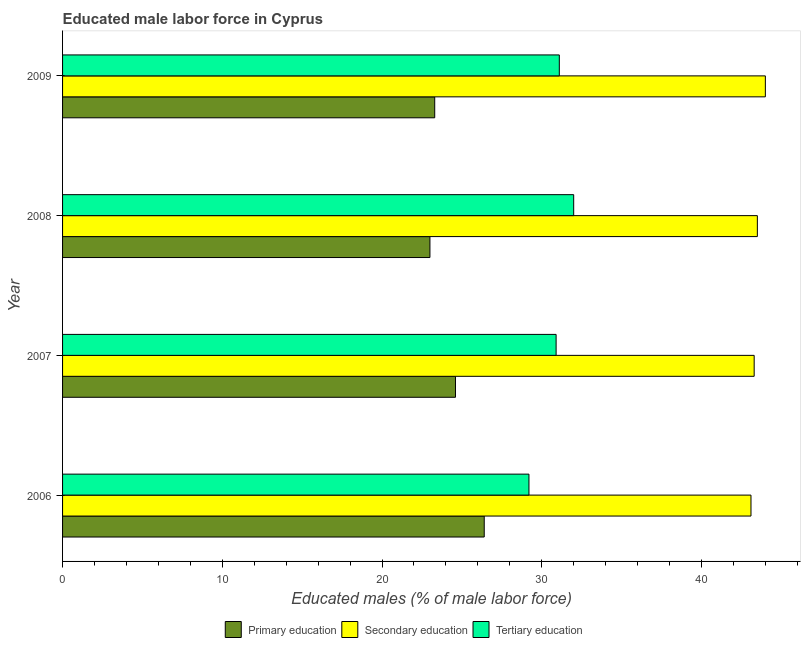How many different coloured bars are there?
Your answer should be compact. 3. How many groups of bars are there?
Your answer should be very brief. 4. Are the number of bars on each tick of the Y-axis equal?
Provide a succinct answer. Yes. What is the label of the 1st group of bars from the top?
Make the answer very short. 2009. In how many cases, is the number of bars for a given year not equal to the number of legend labels?
Provide a succinct answer. 0. What is the percentage of male labor force who received secondary education in 2007?
Provide a short and direct response. 43.3. In which year was the percentage of male labor force who received primary education maximum?
Make the answer very short. 2006. What is the total percentage of male labor force who received primary education in the graph?
Provide a short and direct response. 97.3. What is the difference between the percentage of male labor force who received tertiary education in 2006 and the percentage of male labor force who received primary education in 2009?
Make the answer very short. 5.9. What is the average percentage of male labor force who received secondary education per year?
Your answer should be compact. 43.48. In the year 2006, what is the difference between the percentage of male labor force who received primary education and percentage of male labor force who received secondary education?
Provide a succinct answer. -16.7. What is the ratio of the percentage of male labor force who received tertiary education in 2006 to that in 2007?
Your answer should be very brief. 0.94. Is the difference between the percentage of male labor force who received tertiary education in 2006 and 2009 greater than the difference between the percentage of male labor force who received primary education in 2006 and 2009?
Your answer should be very brief. No. In how many years, is the percentage of male labor force who received tertiary education greater than the average percentage of male labor force who received tertiary education taken over all years?
Give a very brief answer. 3. What does the 2nd bar from the top in 2006 represents?
Offer a terse response. Secondary education. What does the 1st bar from the bottom in 2007 represents?
Your answer should be compact. Primary education. Is it the case that in every year, the sum of the percentage of male labor force who received primary education and percentage of male labor force who received secondary education is greater than the percentage of male labor force who received tertiary education?
Ensure brevity in your answer.  Yes. Are all the bars in the graph horizontal?
Provide a succinct answer. Yes. How many years are there in the graph?
Offer a terse response. 4. What is the difference between two consecutive major ticks on the X-axis?
Keep it short and to the point. 10. Where does the legend appear in the graph?
Your answer should be very brief. Bottom center. What is the title of the graph?
Ensure brevity in your answer.  Educated male labor force in Cyprus. Does "Travel services" appear as one of the legend labels in the graph?
Your response must be concise. No. What is the label or title of the X-axis?
Ensure brevity in your answer.  Educated males (% of male labor force). What is the Educated males (% of male labor force) in Primary education in 2006?
Keep it short and to the point. 26.4. What is the Educated males (% of male labor force) of Secondary education in 2006?
Your answer should be compact. 43.1. What is the Educated males (% of male labor force) of Tertiary education in 2006?
Offer a terse response. 29.2. What is the Educated males (% of male labor force) in Primary education in 2007?
Make the answer very short. 24.6. What is the Educated males (% of male labor force) in Secondary education in 2007?
Your response must be concise. 43.3. What is the Educated males (% of male labor force) in Tertiary education in 2007?
Ensure brevity in your answer.  30.9. What is the Educated males (% of male labor force) in Primary education in 2008?
Your answer should be compact. 23. What is the Educated males (% of male labor force) in Secondary education in 2008?
Ensure brevity in your answer.  43.5. What is the Educated males (% of male labor force) of Primary education in 2009?
Your answer should be very brief. 23.3. What is the Educated males (% of male labor force) of Secondary education in 2009?
Give a very brief answer. 44. What is the Educated males (% of male labor force) in Tertiary education in 2009?
Offer a very short reply. 31.1. Across all years, what is the maximum Educated males (% of male labor force) in Primary education?
Offer a very short reply. 26.4. Across all years, what is the maximum Educated males (% of male labor force) in Secondary education?
Ensure brevity in your answer.  44. Across all years, what is the maximum Educated males (% of male labor force) of Tertiary education?
Offer a very short reply. 32. Across all years, what is the minimum Educated males (% of male labor force) of Primary education?
Ensure brevity in your answer.  23. Across all years, what is the minimum Educated males (% of male labor force) of Secondary education?
Ensure brevity in your answer.  43.1. Across all years, what is the minimum Educated males (% of male labor force) in Tertiary education?
Keep it short and to the point. 29.2. What is the total Educated males (% of male labor force) of Primary education in the graph?
Offer a very short reply. 97.3. What is the total Educated males (% of male labor force) in Secondary education in the graph?
Keep it short and to the point. 173.9. What is the total Educated males (% of male labor force) of Tertiary education in the graph?
Offer a very short reply. 123.2. What is the difference between the Educated males (% of male labor force) of Primary education in 2006 and that in 2007?
Make the answer very short. 1.8. What is the difference between the Educated males (% of male labor force) in Tertiary education in 2006 and that in 2007?
Your response must be concise. -1.7. What is the difference between the Educated males (% of male labor force) of Primary education in 2006 and that in 2008?
Provide a short and direct response. 3.4. What is the difference between the Educated males (% of male labor force) in Secondary education in 2006 and that in 2009?
Offer a terse response. -0.9. What is the difference between the Educated males (% of male labor force) in Tertiary education in 2007 and that in 2008?
Offer a very short reply. -1.1. What is the difference between the Educated males (% of male labor force) in Primary education in 2007 and that in 2009?
Give a very brief answer. 1.3. What is the difference between the Educated males (% of male labor force) of Secondary education in 2007 and that in 2009?
Your response must be concise. -0.7. What is the difference between the Educated males (% of male labor force) of Primary education in 2008 and that in 2009?
Offer a very short reply. -0.3. What is the difference between the Educated males (% of male labor force) of Tertiary education in 2008 and that in 2009?
Your response must be concise. 0.9. What is the difference between the Educated males (% of male labor force) of Primary education in 2006 and the Educated males (% of male labor force) of Secondary education in 2007?
Ensure brevity in your answer.  -16.9. What is the difference between the Educated males (% of male labor force) in Primary education in 2006 and the Educated males (% of male labor force) in Tertiary education in 2007?
Make the answer very short. -4.5. What is the difference between the Educated males (% of male labor force) of Primary education in 2006 and the Educated males (% of male labor force) of Secondary education in 2008?
Your response must be concise. -17.1. What is the difference between the Educated males (% of male labor force) of Secondary education in 2006 and the Educated males (% of male labor force) of Tertiary education in 2008?
Give a very brief answer. 11.1. What is the difference between the Educated males (% of male labor force) in Primary education in 2006 and the Educated males (% of male labor force) in Secondary education in 2009?
Your answer should be compact. -17.6. What is the difference between the Educated males (% of male labor force) of Primary education in 2006 and the Educated males (% of male labor force) of Tertiary education in 2009?
Provide a short and direct response. -4.7. What is the difference between the Educated males (% of male labor force) of Primary education in 2007 and the Educated males (% of male labor force) of Secondary education in 2008?
Offer a very short reply. -18.9. What is the difference between the Educated males (% of male labor force) in Primary education in 2007 and the Educated males (% of male labor force) in Tertiary education in 2008?
Ensure brevity in your answer.  -7.4. What is the difference between the Educated males (% of male labor force) in Secondary education in 2007 and the Educated males (% of male labor force) in Tertiary education in 2008?
Provide a succinct answer. 11.3. What is the difference between the Educated males (% of male labor force) of Primary education in 2007 and the Educated males (% of male labor force) of Secondary education in 2009?
Your response must be concise. -19.4. What is the difference between the Educated males (% of male labor force) of Primary education in 2008 and the Educated males (% of male labor force) of Tertiary education in 2009?
Provide a succinct answer. -8.1. What is the difference between the Educated males (% of male labor force) of Secondary education in 2008 and the Educated males (% of male labor force) of Tertiary education in 2009?
Provide a succinct answer. 12.4. What is the average Educated males (% of male labor force) of Primary education per year?
Keep it short and to the point. 24.32. What is the average Educated males (% of male labor force) of Secondary education per year?
Make the answer very short. 43.48. What is the average Educated males (% of male labor force) in Tertiary education per year?
Provide a succinct answer. 30.8. In the year 2006, what is the difference between the Educated males (% of male labor force) of Primary education and Educated males (% of male labor force) of Secondary education?
Offer a terse response. -16.7. In the year 2007, what is the difference between the Educated males (% of male labor force) in Primary education and Educated males (% of male labor force) in Secondary education?
Give a very brief answer. -18.7. In the year 2007, what is the difference between the Educated males (% of male labor force) of Secondary education and Educated males (% of male labor force) of Tertiary education?
Offer a terse response. 12.4. In the year 2008, what is the difference between the Educated males (% of male labor force) of Primary education and Educated males (% of male labor force) of Secondary education?
Your answer should be compact. -20.5. In the year 2008, what is the difference between the Educated males (% of male labor force) of Primary education and Educated males (% of male labor force) of Tertiary education?
Your response must be concise. -9. In the year 2009, what is the difference between the Educated males (% of male labor force) of Primary education and Educated males (% of male labor force) of Secondary education?
Provide a short and direct response. -20.7. In the year 2009, what is the difference between the Educated males (% of male labor force) in Secondary education and Educated males (% of male labor force) in Tertiary education?
Give a very brief answer. 12.9. What is the ratio of the Educated males (% of male labor force) in Primary education in 2006 to that in 2007?
Ensure brevity in your answer.  1.07. What is the ratio of the Educated males (% of male labor force) of Secondary education in 2006 to that in 2007?
Your answer should be very brief. 1. What is the ratio of the Educated males (% of male labor force) in Tertiary education in 2006 to that in 2007?
Your response must be concise. 0.94. What is the ratio of the Educated males (% of male labor force) in Primary education in 2006 to that in 2008?
Offer a very short reply. 1.15. What is the ratio of the Educated males (% of male labor force) of Tertiary education in 2006 to that in 2008?
Keep it short and to the point. 0.91. What is the ratio of the Educated males (% of male labor force) of Primary education in 2006 to that in 2009?
Provide a succinct answer. 1.13. What is the ratio of the Educated males (% of male labor force) in Secondary education in 2006 to that in 2009?
Provide a succinct answer. 0.98. What is the ratio of the Educated males (% of male labor force) in Tertiary education in 2006 to that in 2009?
Your response must be concise. 0.94. What is the ratio of the Educated males (% of male labor force) of Primary education in 2007 to that in 2008?
Offer a terse response. 1.07. What is the ratio of the Educated males (% of male labor force) of Secondary education in 2007 to that in 2008?
Offer a very short reply. 1. What is the ratio of the Educated males (% of male labor force) in Tertiary education in 2007 to that in 2008?
Provide a succinct answer. 0.97. What is the ratio of the Educated males (% of male labor force) of Primary education in 2007 to that in 2009?
Your answer should be compact. 1.06. What is the ratio of the Educated males (% of male labor force) of Secondary education in 2007 to that in 2009?
Your answer should be compact. 0.98. What is the ratio of the Educated males (% of male labor force) in Primary education in 2008 to that in 2009?
Ensure brevity in your answer.  0.99. What is the ratio of the Educated males (% of male labor force) of Secondary education in 2008 to that in 2009?
Make the answer very short. 0.99. What is the ratio of the Educated males (% of male labor force) in Tertiary education in 2008 to that in 2009?
Your answer should be very brief. 1.03. What is the difference between the highest and the second highest Educated males (% of male labor force) in Secondary education?
Provide a succinct answer. 0.5. What is the difference between the highest and the second highest Educated males (% of male labor force) of Tertiary education?
Your answer should be very brief. 0.9. What is the difference between the highest and the lowest Educated males (% of male labor force) in Primary education?
Make the answer very short. 3.4. What is the difference between the highest and the lowest Educated males (% of male labor force) in Tertiary education?
Your response must be concise. 2.8. 